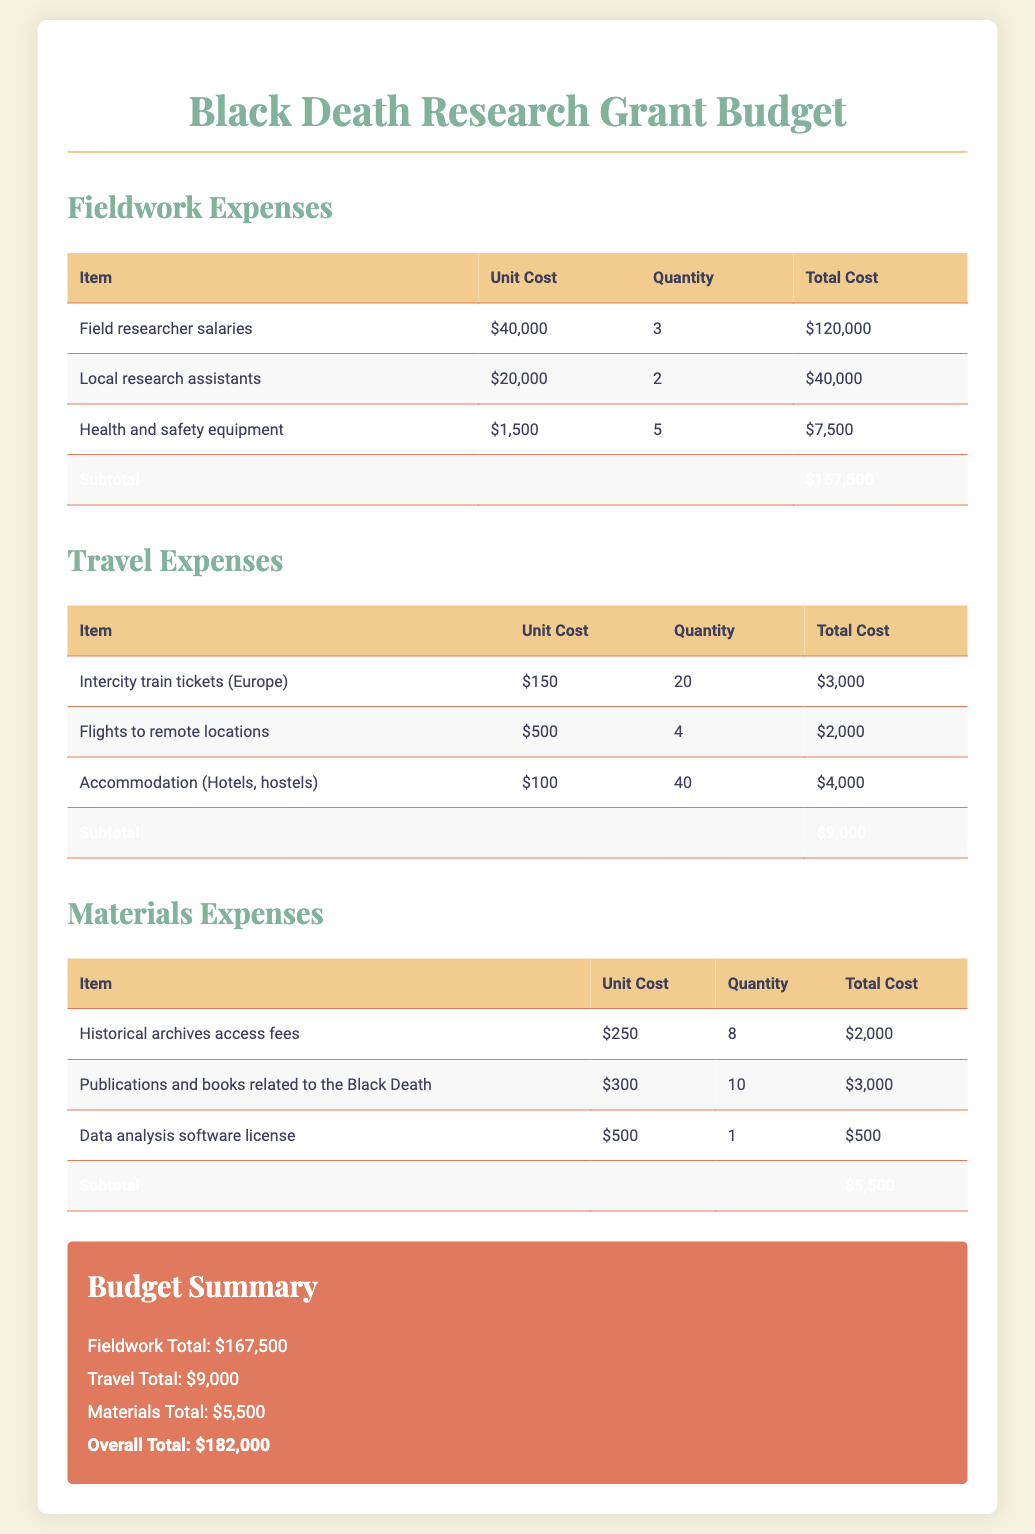What is the total cost for field researcher salaries? The total cost for field researcher salaries is calculated by multiplying the unit cost of $40,000 by the quantity of 3, resulting in $120,000.
Answer: $120,000 What is the unit cost for historical archives access fees? The unit cost for historical archives access fees, as provided in the document, is $250.
Answer: $250 What is the subtotal for travel expenses? The subtotal for travel expenses is clearly listed in the document as $9,000.
Answer: $9,000 How many local research assistants are funded? The document specifies that there are 2 local research assistants funded in the fieldwork expenses.
Answer: 2 What is the overall total budget for the project? The overall total budget is provided at the end of the document, which sums up all expenses to $182,000.
Answer: $182,000 Which item has the highest unit cost in fieldwork expenses? The item with the highest unit cost in the fieldwork expenses is "Field researcher salaries" at $40,000.
Answer: Field researcher salaries How much is allocated for accommodation in travel expenses? The document allocates $4,000 for accommodation, as indicated in the travel expenses section.
Answer: $4,000 What materials expense has the lowest total cost? The materials expense with the lowest total cost is "Data analysis software license," totaling $500.
Answer: $500 What is the total quantity of historical archives access fees purchased? The total quantity of historical archives access fees purchased is noted in the document as 8.
Answer: 8 